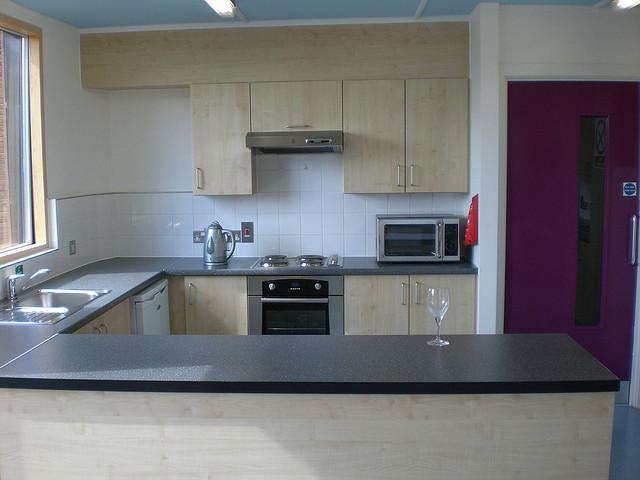How many glasses are on the counter?
Concise answer only. 1. Do you see a toaster on the counter?
Answer briefly. No. What room is this?
Quick response, please. Kitchen. Is that oven new?
Concise answer only. Yes. What type of countertop is the island?
Quick response, please. Granite. Does the kitchen appear unused?
Write a very short answer. Yes. 